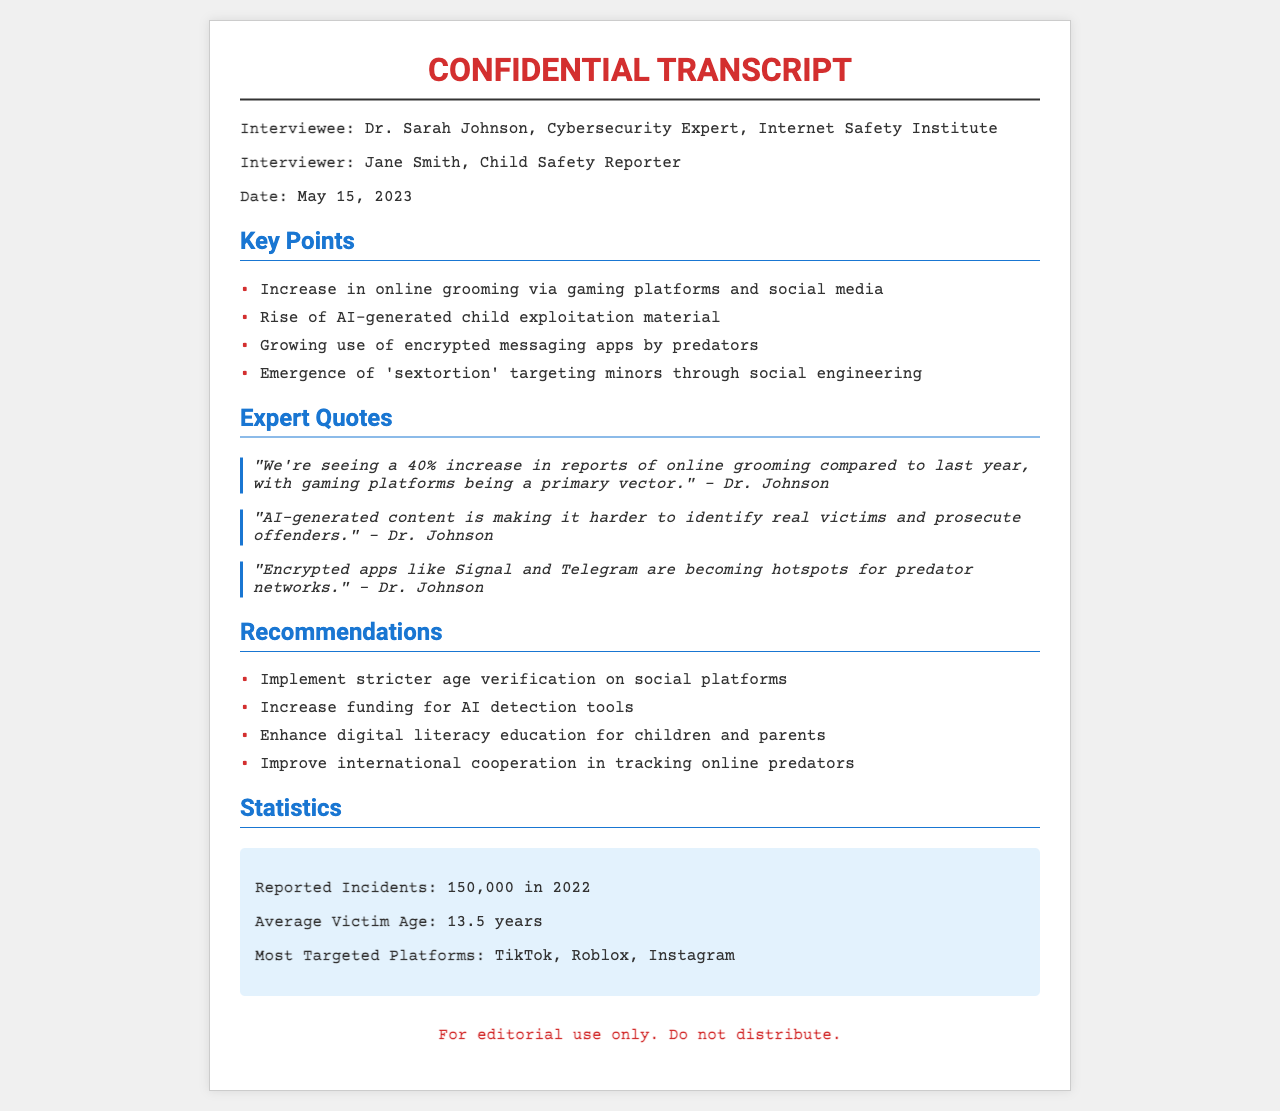What is the date of the interview? The date of the interview is specified in the document as May 15, 2023.
Answer: May 15, 2023 Who conducted the interview? The document indicates that Jane Smith is the interviewer.
Answer: Jane Smith What is the primary vector for online grooming mentioned? The expert quotes identify gaming platforms as a primary vector for online grooming.
Answer: Gaming platforms How much has the increase in reports of online grooming compared to last year? The document states that there is a 40% increase in reports of online grooming.
Answer: 40% What age group is most targeted for online exploitation? The document mentions that the average victim age is 13.5 years.
Answer: 13.5 years Which app is identified as a hotspot for predator networks? The quotes highlight Signal and Telegram as encrypted apps becoming hotspots.
Answer: Signal and Telegram What is the total number of reported incidents in 2022? The statistics section provides the total reported incidents as 150,000 for the year 2022.
Answer: 150,000 What is one of the recommendations for preventing online exploitation? The recommendations include implementing stricter age verification on social platforms.
Answer: Stricter age verification Which platforms are most targeted for exploitation according to the document? The document lists TikTok, Roblox, and Instagram as the most targeted platforms.
Answer: TikTok, Roblox, Instagram 